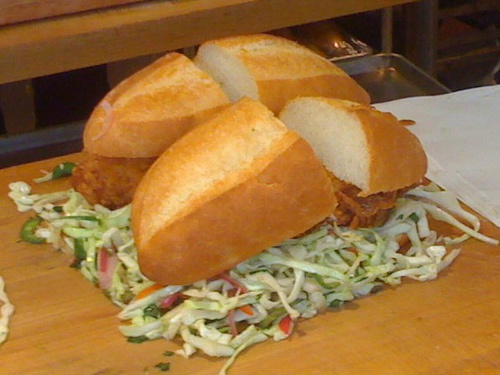Describe the objects in this image and their specific colors. I can see dining table in olive, brown, orange, tan, and darkgray tones, sandwich in brown, red, and orange tones, and sandwich in brown, red, tan, and orange tones in this image. 